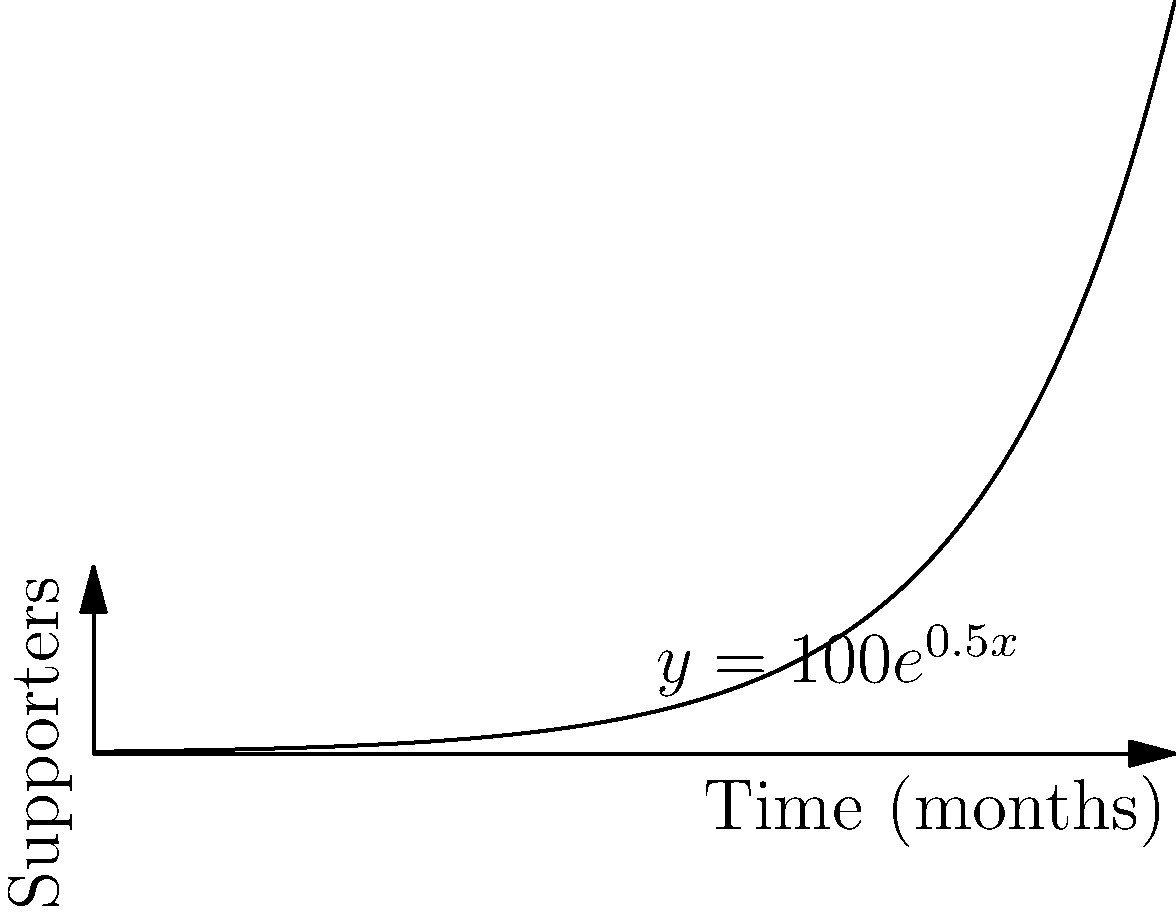As a social justice activist, you're tracking the growth of supporters for your movement. The graph shows the number of supporters over time, following the function $y = 100e^{0.5x}$, where $y$ is the number of supporters and $x$ is the time in months. How many months will it take for the movement to reach 5,000 supporters? Let's approach this step-by-step:

1) We're given the function $y = 100e^{0.5x}$, and we want to find $x$ when $y = 5000$.

2) Let's substitute these values into the equation:
   $5000 = 100e^{0.5x}$

3) Divide both sides by 100:
   $50 = e^{0.5x}$

4) Take the natural log of both sides:
   $\ln(50) = \ln(e^{0.5x})$

5) Simplify the right side using the properties of logarithms:
   $\ln(50) = 0.5x$

6) Divide both sides by 0.5:
   $\frac{\ln(50)}{0.5} = x$

7) Calculate:
   $x = \frac{\ln(50)}{0.5} \approx 7.824$

8) Since we're dealing with months, we need to round up to the nearest whole number.

Therefore, it will take 8 months for the movement to reach 5,000 supporters.
Answer: 8 months 